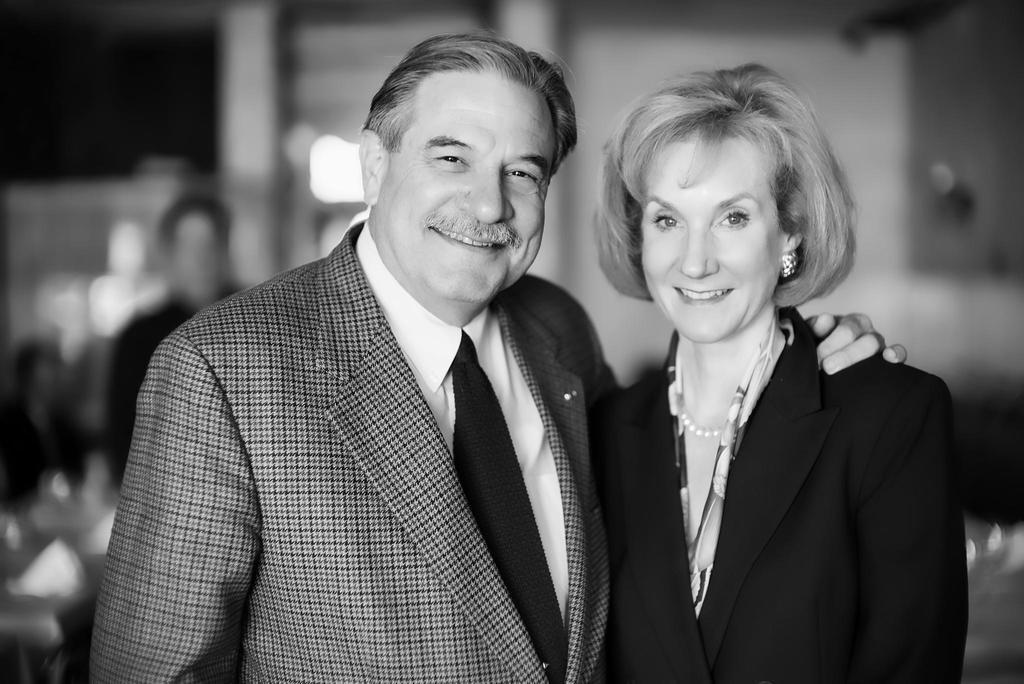Describe this image in one or two sentences. This is a black and white image. In the middle, we can see two people man and women are wearing suits. In the background, we can see a person, tables, chairs. 